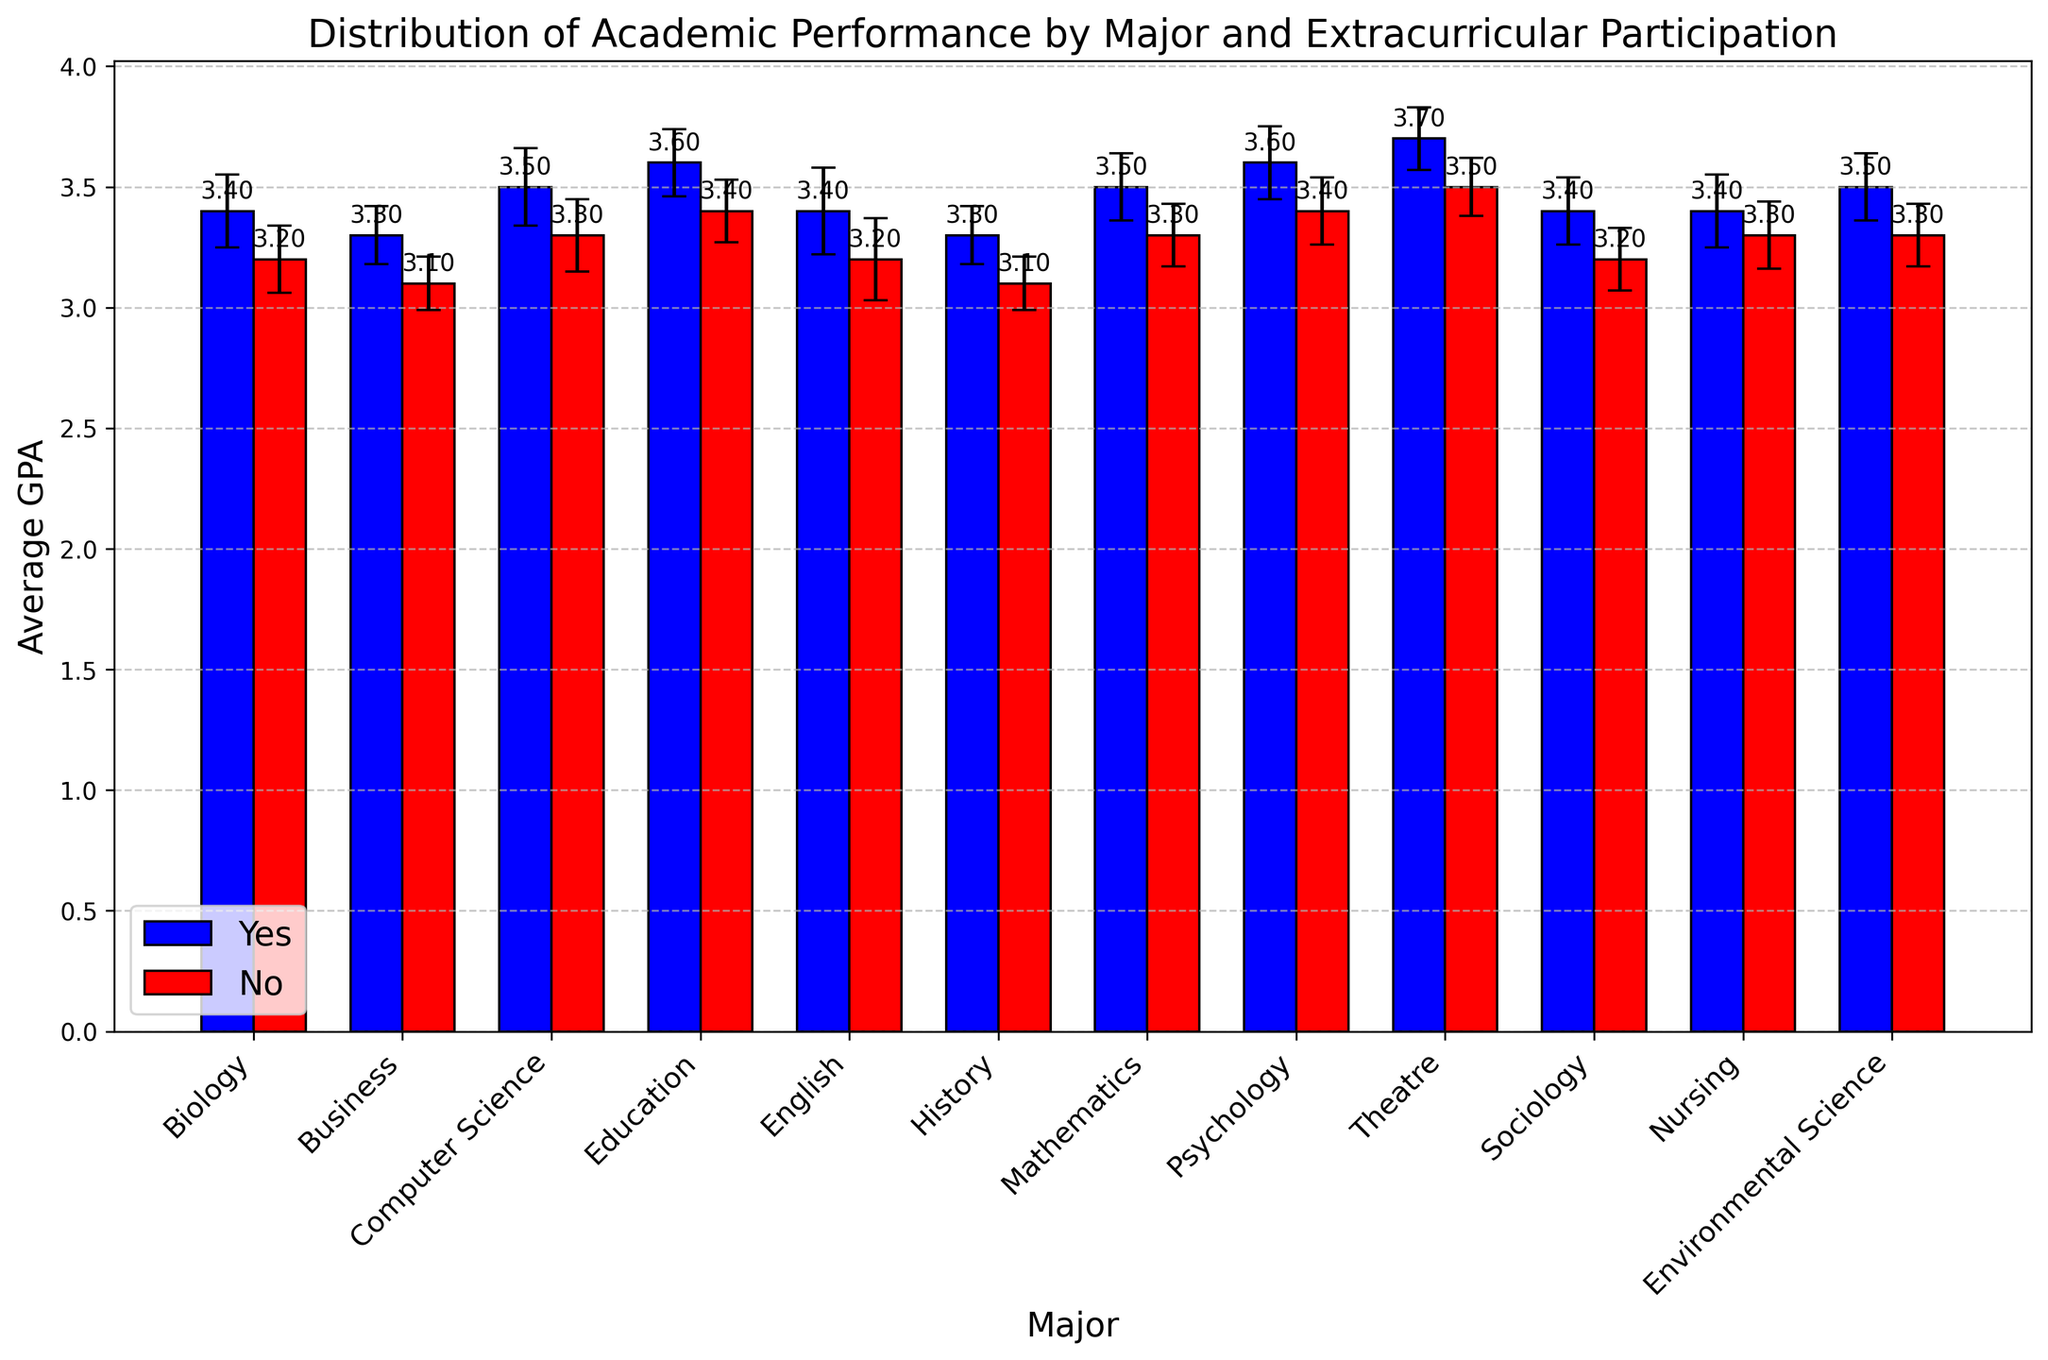Which major has the highest average GPA with extracurricular participation? Observing the heights of the blue bars, Theatre has the highest average GPA for students with extracurricular participation, which is labeled as 3.7.
Answer: Theatre Which major shows the largest difference in average GPA between students who do and do not participate in extracurricular activities? By the visual comparison of the bar differences, Theatre shows the largest difference where extracurricular participants have an average GPA of 3.7 and non-participants have 3.5, which is a difference of 0.2.
Answer: Theatre Are there any majors where students with extracurricular participation have a lower average GPA than those without? By comparing the heights of the blue and red bars for each major, there are no majors where the red bars (non-participants) exceed the blue bars (participants) in height; all blue bars are higher.
Answer: No In which major do students without extracurricular participation have the highest average GPA? Observing the red bars, Theatre stands out with the highest average GPA of non-participants, labeled as 3.5.
Answer: Theatre Which major has the smallest standard deviation in average GPA for students with extracurricular participation? The standard deviation is represented by the error bars; Business has the smallest error bar (std deviation 0.12) in students with extracurricular participation among all majors.
Answer: Business How much higher is the average GPA for Education majors with extracurricular participation compared to those without? The average GPA for Education majors with extracurricular participation is 3.6, and without is 3.4. Subtracting these values gives 3.6 - 3.4 = 0.2.
Answer: 0.2 Which group has a larger average GPA: Business majors with extracurricular participation or Psychology majors without extracurricular participation? Comparing the respective bar heights, Business majors with extracurricular participation have an average GPA of 3.3, while Psychology majors without extracurricular participation have an average GPA of 3.4. The latter is higher.
Answer: Psychology majors without What is the average GPA of Mathematics majors regardless of extracurricular participation? Mathematics majors with extracurricular participation have an average GPA of 3.5, and without have 3.3. Adding these and dividing by 2 gives (3.5 + 3.3) / 2 = 3.4.
Answer: 3.4 Which majors have an average GPA of 3.4 for students with extracurricular participation? From the blue bars, Biology, English, Sociology, and Nursing all have labels indicating an average GPA of 3.4 for students with extracurricular participation.
Answer: Biology, English, Sociology, Nursing 